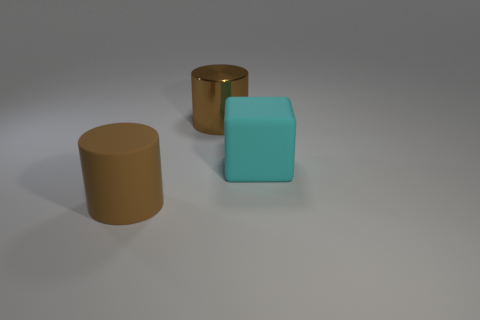There is a large matte thing behind the big cylinder that is on the left side of the metal thing; what is its color?
Offer a very short reply. Cyan. What number of tiny objects are either yellow metallic spheres or brown matte objects?
Give a very brief answer. 0. There is another object that is the same shape as the big brown metal object; what is its material?
Provide a succinct answer. Rubber. Are there any other things that have the same material as the large block?
Offer a very short reply. Yes. What is the color of the rubber cylinder?
Ensure brevity in your answer.  Brown. Is the block the same color as the large metal cylinder?
Keep it short and to the point. No. What number of big brown metallic things are in front of the object that is behind the big cyan matte thing?
Your answer should be very brief. 0. What size is the object that is in front of the large brown metal cylinder and left of the cyan matte object?
Offer a very short reply. Large. There is a cylinder that is on the left side of the large brown shiny thing; what is its material?
Offer a terse response. Rubber. Is there another large cyan rubber thing that has the same shape as the cyan rubber object?
Keep it short and to the point. No. 